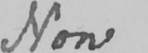Transcribe the text shown in this historical manuscript line. Now 